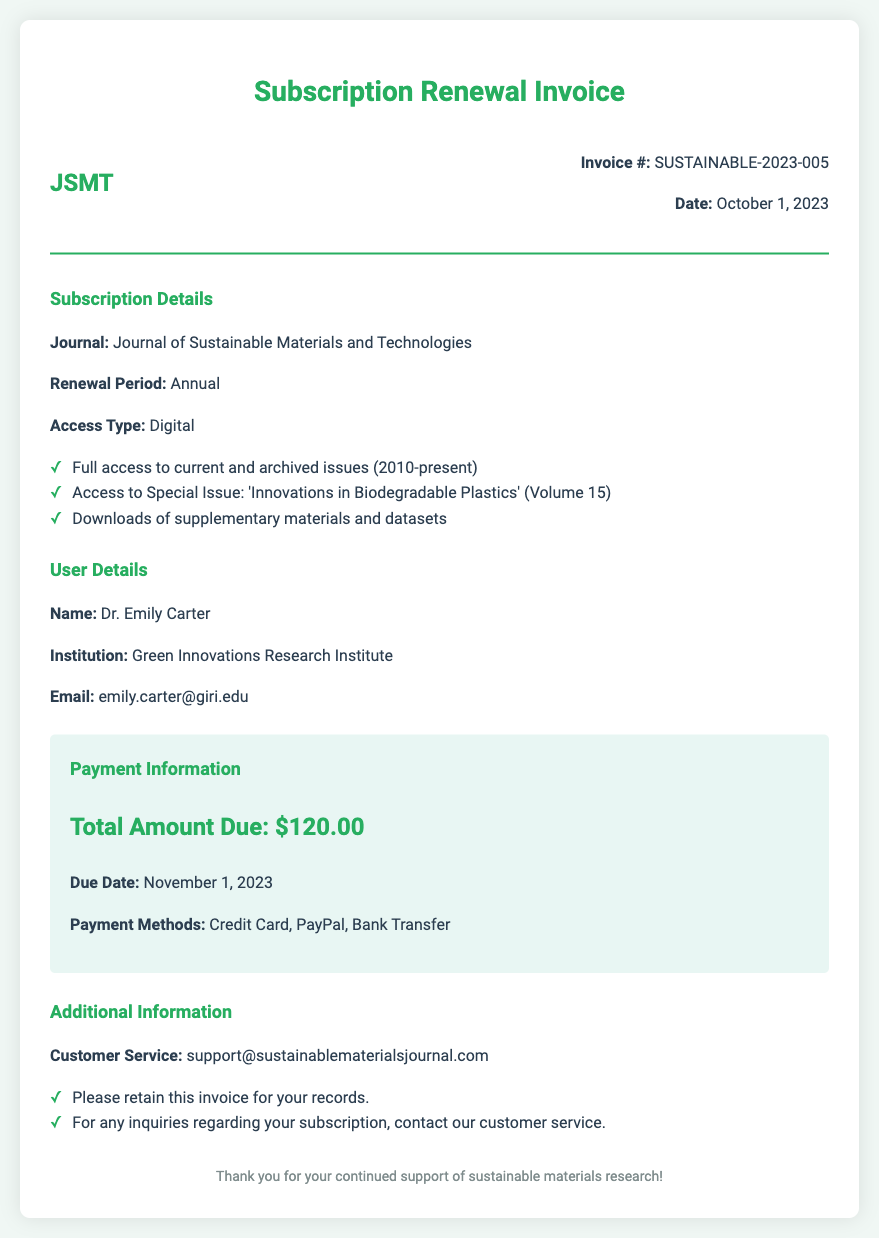What is the invoice number? The invoice number is listed prominently in the document details section.
Answer: SUSTAINABLE-2023-005 When is the payment due? The due date for the payment is mentioned in the payment information section.
Answer: November 1, 2023 What is the total amount due? The total amount due is clearly stated in the payment information section.
Answer: $120.00 What journal is this invoice for? The specific journal associated with this subscription is mentioned under subscription details.
Answer: Journal of Sustainable Materials and Technologies What special issue is included in the subscription? The title of the special issue is outlined in the subscription details.
Answer: Innovations in Biodegradable Plastics Who is the recipient of this invoice? The name of the individual to whom the invoice is addressed is provided in the user details section.
Answer: Dr. Emily Carter What is the renewal period for the subscription? The renewal period is specified in the subscription details section of the document.
Answer: Annual What payment methods are accepted? The document specifies the various payment methods available in the payment information section.
Answer: Credit Card, PayPal, Bank Transfer 